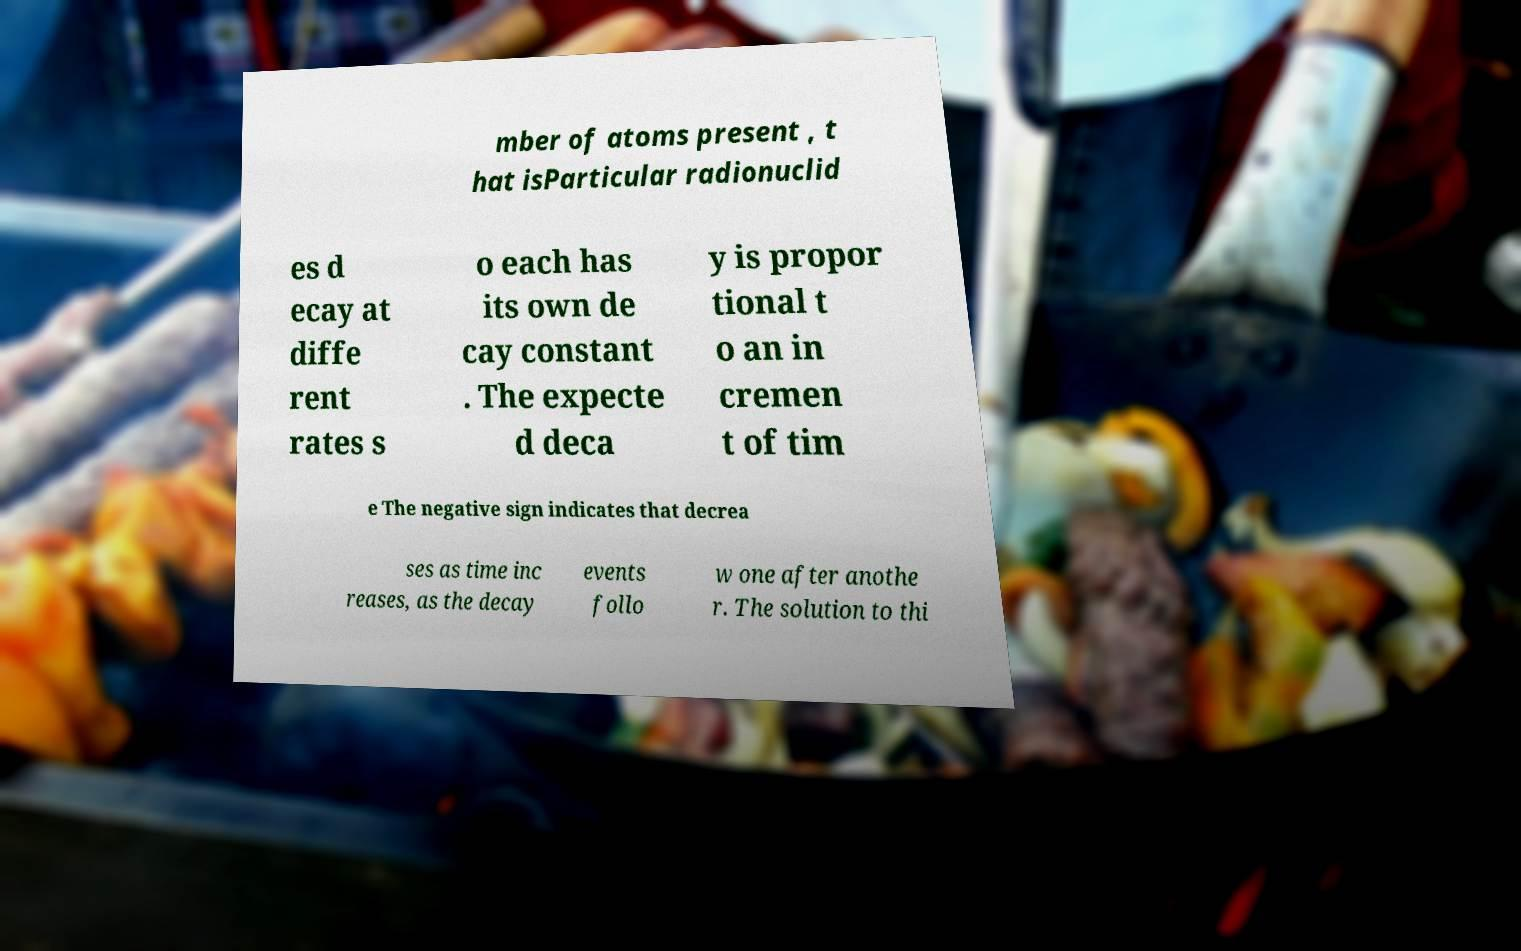Please identify and transcribe the text found in this image. mber of atoms present , t hat isParticular radionuclid es d ecay at diffe rent rates s o each has its own de cay constant . The expecte d deca y is propor tional t o an in cremen t of tim e The negative sign indicates that decrea ses as time inc reases, as the decay events follo w one after anothe r. The solution to thi 